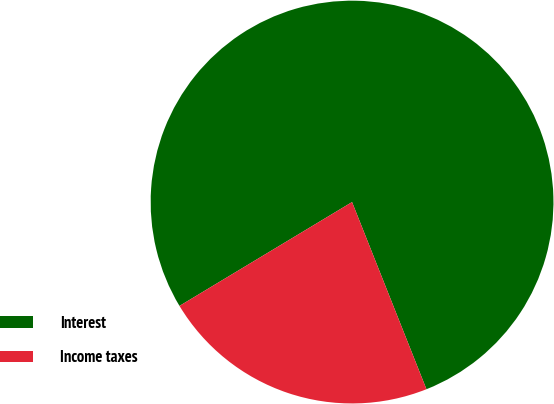Convert chart. <chart><loc_0><loc_0><loc_500><loc_500><pie_chart><fcel>Interest<fcel>Income taxes<nl><fcel>77.6%<fcel>22.4%<nl></chart> 